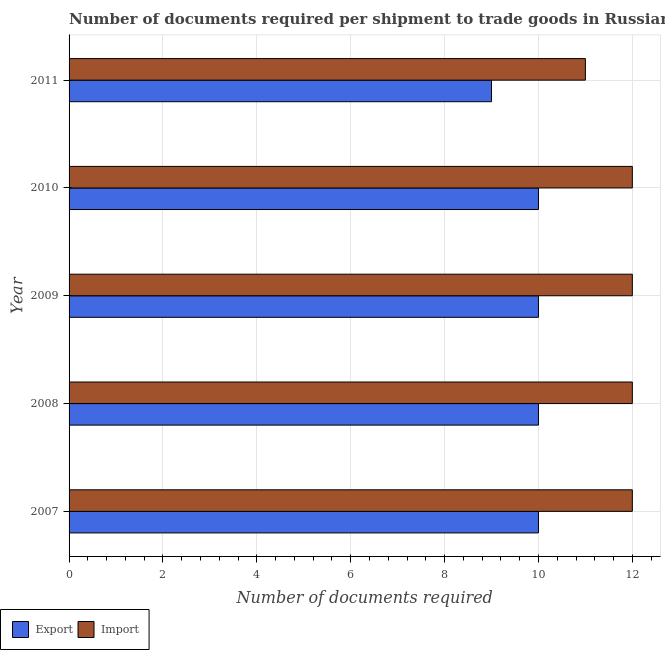Are the number of bars on each tick of the Y-axis equal?
Provide a succinct answer. Yes. How many bars are there on the 5th tick from the top?
Give a very brief answer. 2. In how many cases, is the number of bars for a given year not equal to the number of legend labels?
Provide a succinct answer. 0. What is the number of documents required to import goods in 2011?
Offer a very short reply. 11. Across all years, what is the maximum number of documents required to import goods?
Offer a very short reply. 12. Across all years, what is the minimum number of documents required to export goods?
Offer a terse response. 9. In which year was the number of documents required to import goods minimum?
Make the answer very short. 2011. What is the total number of documents required to import goods in the graph?
Provide a succinct answer. 59. What is the difference between the number of documents required to import goods in 2007 and that in 2009?
Give a very brief answer. 0. What is the difference between the number of documents required to export goods in 2008 and the number of documents required to import goods in 2009?
Give a very brief answer. -2. What is the average number of documents required to import goods per year?
Offer a terse response. 11.8. In the year 2009, what is the difference between the number of documents required to import goods and number of documents required to export goods?
Ensure brevity in your answer.  2. In how many years, is the number of documents required to export goods greater than 9.6 ?
Ensure brevity in your answer.  4. What is the ratio of the number of documents required to export goods in 2008 to that in 2009?
Provide a short and direct response. 1. What is the difference between the highest and the second highest number of documents required to export goods?
Your answer should be compact. 0. What is the difference between the highest and the lowest number of documents required to import goods?
Offer a very short reply. 1. In how many years, is the number of documents required to import goods greater than the average number of documents required to import goods taken over all years?
Provide a succinct answer. 4. What does the 1st bar from the top in 2007 represents?
Give a very brief answer. Import. What does the 1st bar from the bottom in 2010 represents?
Your answer should be very brief. Export. How many years are there in the graph?
Give a very brief answer. 5. What is the difference between two consecutive major ticks on the X-axis?
Keep it short and to the point. 2. Are the values on the major ticks of X-axis written in scientific E-notation?
Provide a short and direct response. No. Does the graph contain grids?
Your response must be concise. Yes. Where does the legend appear in the graph?
Keep it short and to the point. Bottom left. What is the title of the graph?
Provide a succinct answer. Number of documents required per shipment to trade goods in Russian Federation. What is the label or title of the X-axis?
Your answer should be very brief. Number of documents required. What is the label or title of the Y-axis?
Offer a very short reply. Year. What is the Number of documents required in Export in 2007?
Provide a short and direct response. 10. What is the Number of documents required of Import in 2007?
Your answer should be very brief. 12. What is the Number of documents required of Export in 2008?
Give a very brief answer. 10. What is the Number of documents required of Import in 2008?
Give a very brief answer. 12. What is the Number of documents required of Import in 2009?
Keep it short and to the point. 12. What is the Number of documents required of Export in 2010?
Offer a very short reply. 10. What is the Number of documents required in Import in 2010?
Your answer should be very brief. 12. Across all years, what is the minimum Number of documents required of Export?
Offer a very short reply. 9. Across all years, what is the minimum Number of documents required in Import?
Give a very brief answer. 11. What is the total Number of documents required of Export in the graph?
Your response must be concise. 49. What is the difference between the Number of documents required in Import in 2007 and that in 2008?
Offer a very short reply. 0. What is the difference between the Number of documents required in Export in 2007 and that in 2010?
Provide a succinct answer. 0. What is the difference between the Number of documents required in Import in 2007 and that in 2010?
Your answer should be very brief. 0. What is the difference between the Number of documents required of Export in 2007 and that in 2011?
Offer a very short reply. 1. What is the difference between the Number of documents required of Import in 2007 and that in 2011?
Keep it short and to the point. 1. What is the difference between the Number of documents required of Export in 2008 and that in 2009?
Make the answer very short. 0. What is the difference between the Number of documents required in Export in 2008 and that in 2010?
Make the answer very short. 0. What is the difference between the Number of documents required in Import in 2008 and that in 2010?
Offer a very short reply. 0. What is the difference between the Number of documents required of Import in 2009 and that in 2010?
Keep it short and to the point. 0. What is the difference between the Number of documents required of Import in 2009 and that in 2011?
Your answer should be compact. 1. What is the difference between the Number of documents required of Export in 2010 and that in 2011?
Your response must be concise. 1. What is the difference between the Number of documents required in Import in 2010 and that in 2011?
Offer a very short reply. 1. What is the difference between the Number of documents required in Export in 2007 and the Number of documents required in Import in 2009?
Your answer should be compact. -2. What is the difference between the Number of documents required of Export in 2008 and the Number of documents required of Import in 2010?
Your answer should be very brief. -2. What is the difference between the Number of documents required in Export in 2009 and the Number of documents required in Import in 2010?
Give a very brief answer. -2. What is the difference between the Number of documents required in Export in 2009 and the Number of documents required in Import in 2011?
Your answer should be compact. -1. What is the average Number of documents required of Export per year?
Offer a very short reply. 9.8. What is the average Number of documents required in Import per year?
Your answer should be very brief. 11.8. In the year 2008, what is the difference between the Number of documents required of Export and Number of documents required of Import?
Keep it short and to the point. -2. In the year 2009, what is the difference between the Number of documents required in Export and Number of documents required in Import?
Offer a very short reply. -2. What is the ratio of the Number of documents required in Export in 2007 to that in 2008?
Your answer should be very brief. 1. What is the ratio of the Number of documents required of Import in 2007 to that in 2008?
Provide a succinct answer. 1. What is the ratio of the Number of documents required in Export in 2008 to that in 2011?
Provide a short and direct response. 1.11. What is the ratio of the Number of documents required of Import in 2008 to that in 2011?
Make the answer very short. 1.09. What is the ratio of the Number of documents required of Export in 2009 to that in 2011?
Give a very brief answer. 1.11. What is the ratio of the Number of documents required in Import in 2009 to that in 2011?
Keep it short and to the point. 1.09. What is the ratio of the Number of documents required in Export in 2010 to that in 2011?
Give a very brief answer. 1.11. What is the ratio of the Number of documents required in Import in 2010 to that in 2011?
Offer a very short reply. 1.09. What is the difference between the highest and the second highest Number of documents required of Import?
Provide a short and direct response. 0. What is the difference between the highest and the lowest Number of documents required of Import?
Ensure brevity in your answer.  1. 